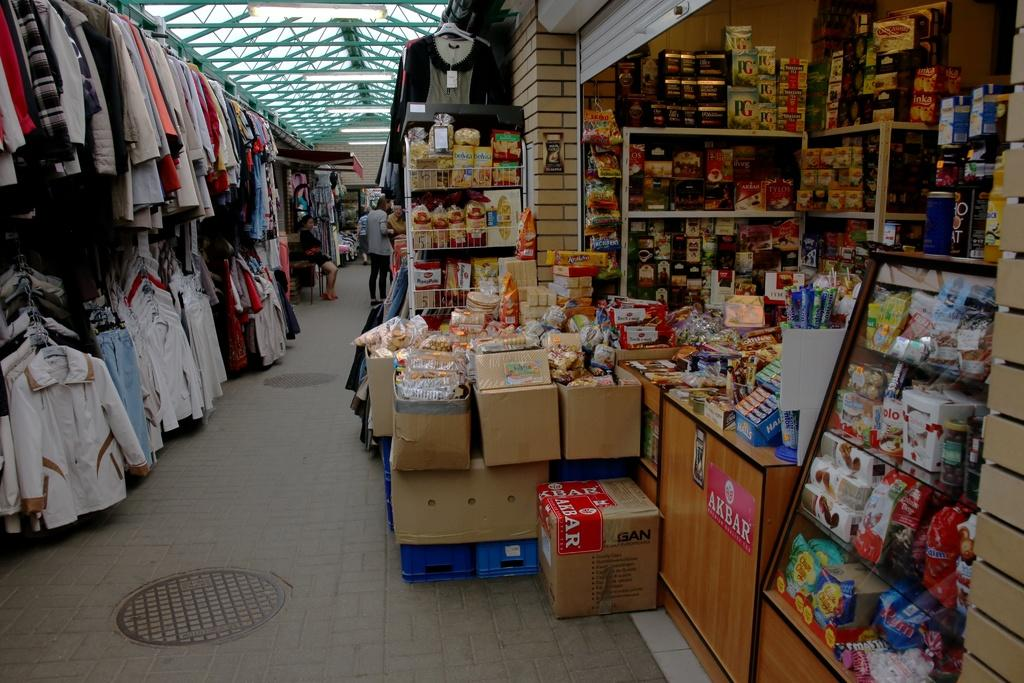<image>
Summarize the visual content of the image. an indoor market which includes boxes that are labeled AKBAR 